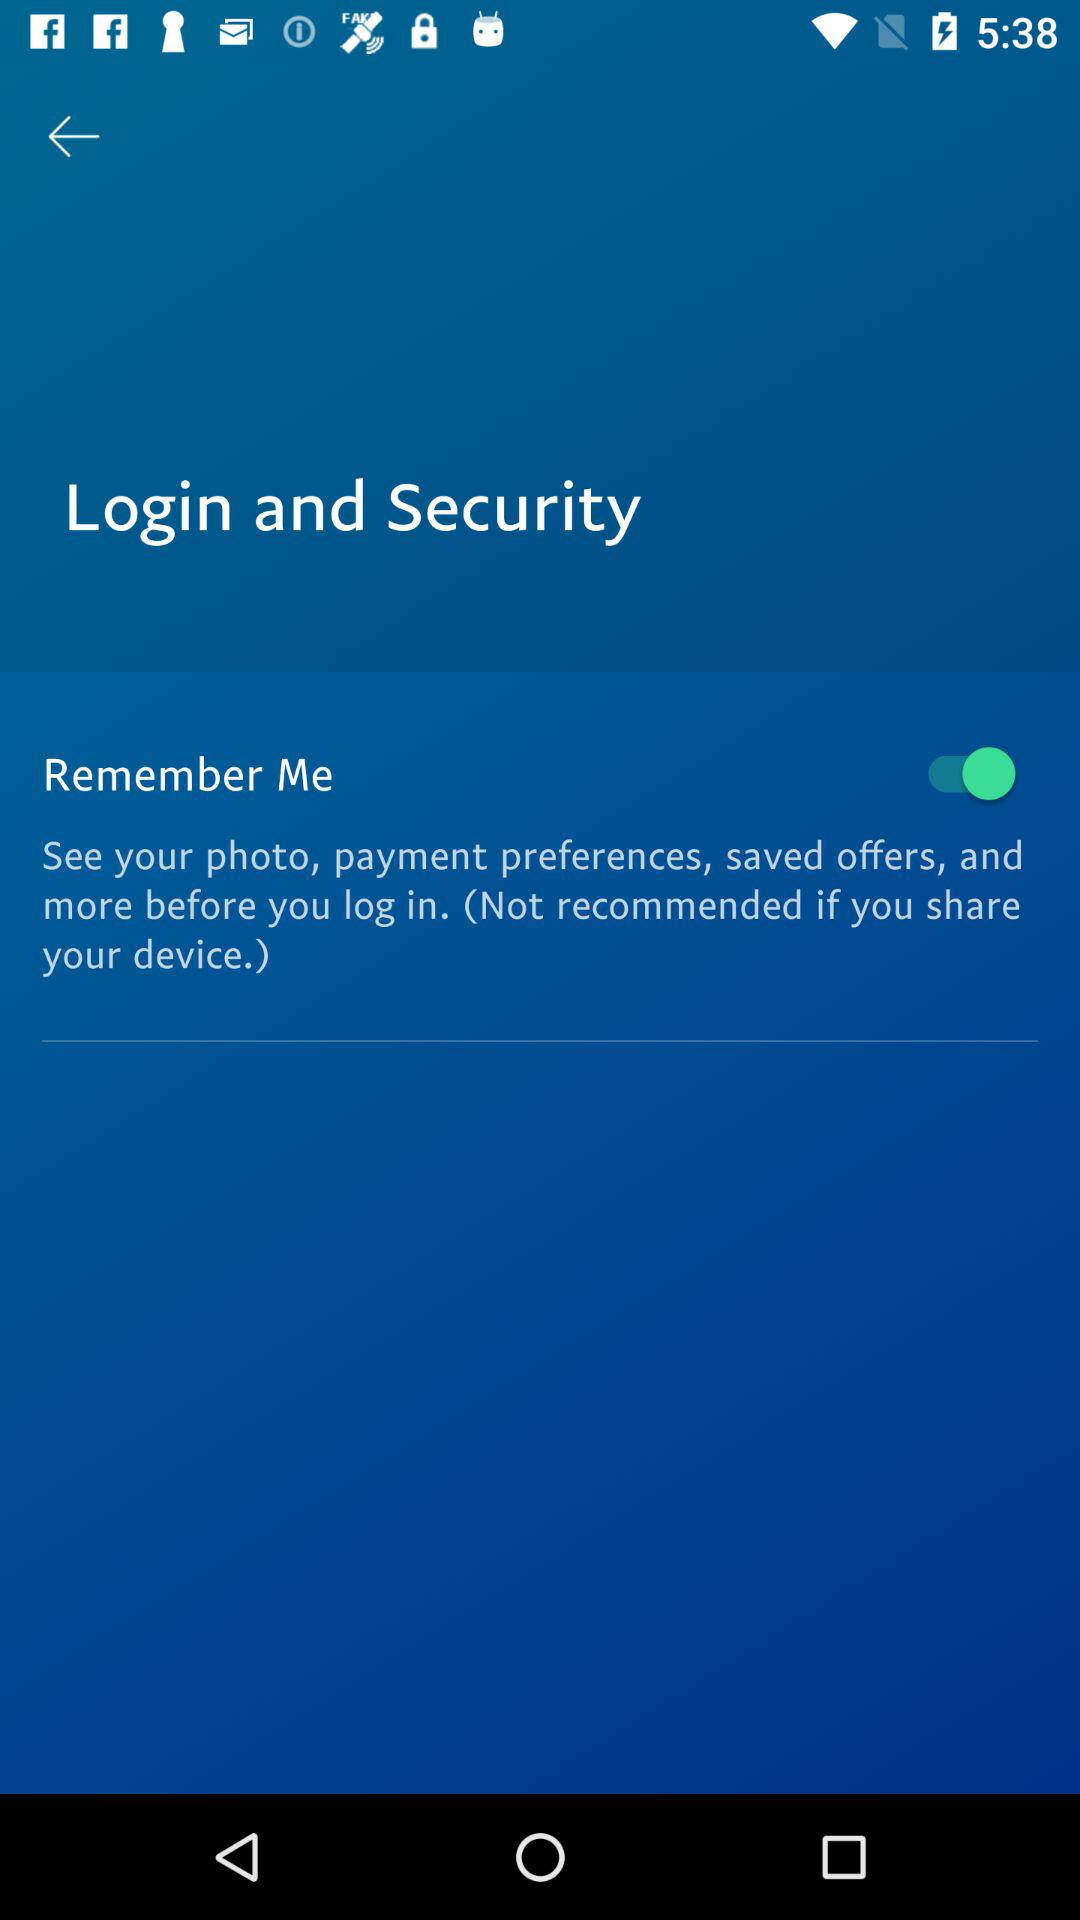What is the current status of the remember me? The current status is on. 